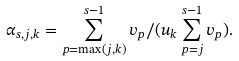<formula> <loc_0><loc_0><loc_500><loc_500>\alpha _ { s , j , k } = \sum _ { p = \max ( j , k ) } ^ { s - 1 } v _ { p } / ( u _ { k } \sum _ { p = j } ^ { s - 1 } v _ { p } ) .</formula> 